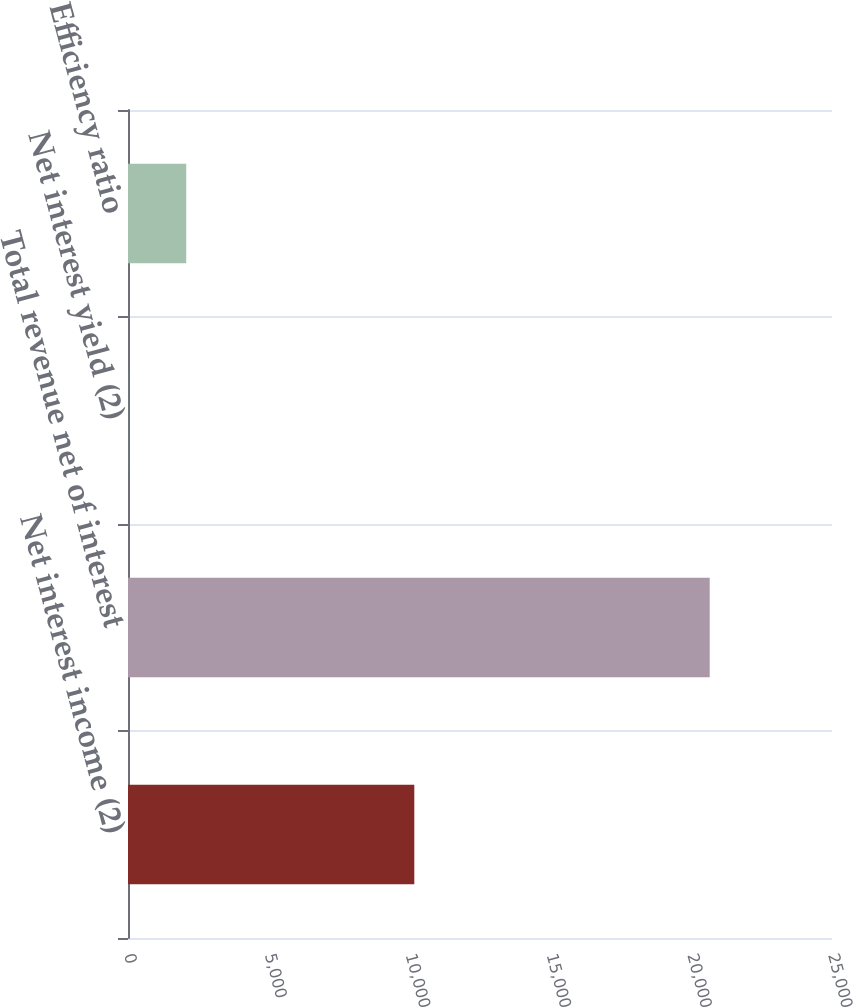Convert chart to OTSL. <chart><loc_0><loc_0><loc_500><loc_500><bar_chart><fcel>Net interest income (2)<fcel>Total revenue net of interest<fcel>Net interest yield (2)<fcel>Efficiency ratio<nl><fcel>10167<fcel>20657<fcel>2.32<fcel>2067.79<nl></chart> 